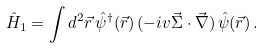<formula> <loc_0><loc_0><loc_500><loc_500>\hat { H } _ { 1 } = \int { d } ^ { 2 } \vec { r } \, \hat { \psi } ^ { \dagger } ( \vec { r } ) \, ( - i v \vec { \Sigma } \cdot \vec { \nabla } ) \, \hat { \psi } ( \vec { r } ) \, .</formula> 